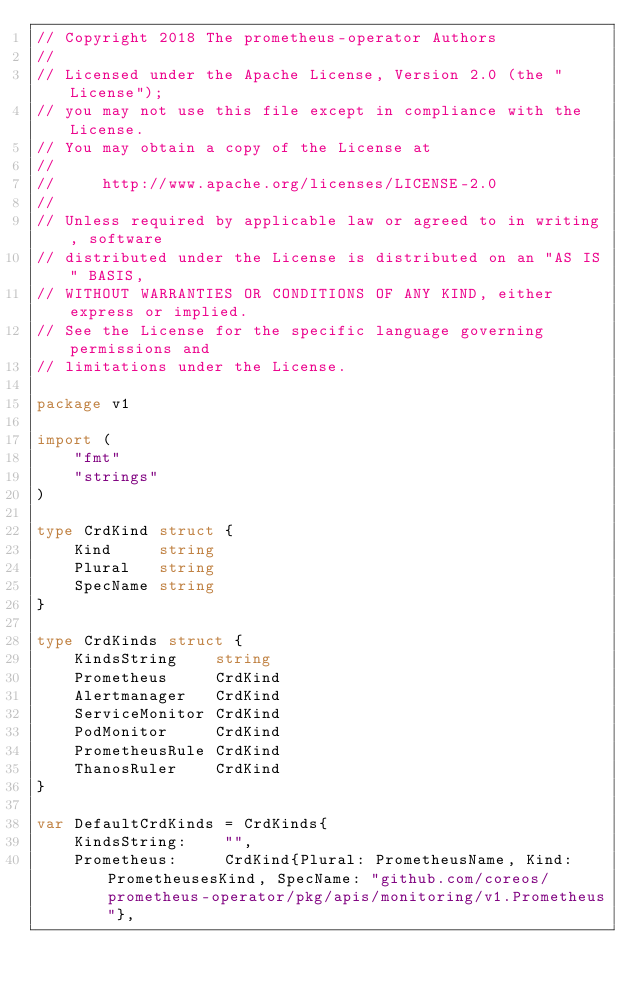Convert code to text. <code><loc_0><loc_0><loc_500><loc_500><_Go_>// Copyright 2018 The prometheus-operator Authors
//
// Licensed under the Apache License, Version 2.0 (the "License");
// you may not use this file except in compliance with the License.
// You may obtain a copy of the License at
//
//     http://www.apache.org/licenses/LICENSE-2.0
//
// Unless required by applicable law or agreed to in writing, software
// distributed under the License is distributed on an "AS IS" BASIS,
// WITHOUT WARRANTIES OR CONDITIONS OF ANY KIND, either express or implied.
// See the License for the specific language governing permissions and
// limitations under the License.

package v1

import (
	"fmt"
	"strings"
)

type CrdKind struct {
	Kind     string
	Plural   string
	SpecName string
}

type CrdKinds struct {
	KindsString    string
	Prometheus     CrdKind
	Alertmanager   CrdKind
	ServiceMonitor CrdKind
	PodMonitor     CrdKind
	PrometheusRule CrdKind
	ThanosRuler    CrdKind
}

var DefaultCrdKinds = CrdKinds{
	KindsString:    "",
	Prometheus:     CrdKind{Plural: PrometheusName, Kind: PrometheusesKind, SpecName: "github.com/coreos/prometheus-operator/pkg/apis/monitoring/v1.Prometheus"},</code> 